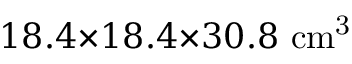Convert formula to latex. <formula><loc_0><loc_0><loc_500><loc_500>1 8 . 4 { \times } 1 8 . 4 { \times } 3 0 . 8 c m ^ { 3 }</formula> 